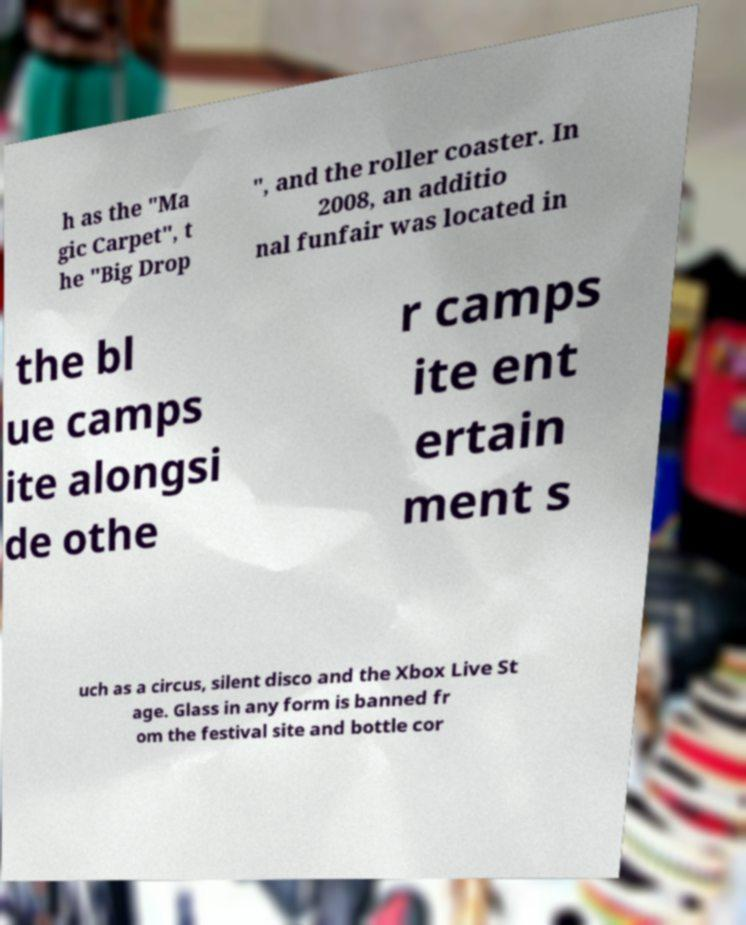There's text embedded in this image that I need extracted. Can you transcribe it verbatim? h as the "Ma gic Carpet", t he "Big Drop ", and the roller coaster. In 2008, an additio nal funfair was located in the bl ue camps ite alongsi de othe r camps ite ent ertain ment s uch as a circus, silent disco and the Xbox Live St age. Glass in any form is banned fr om the festival site and bottle cor 